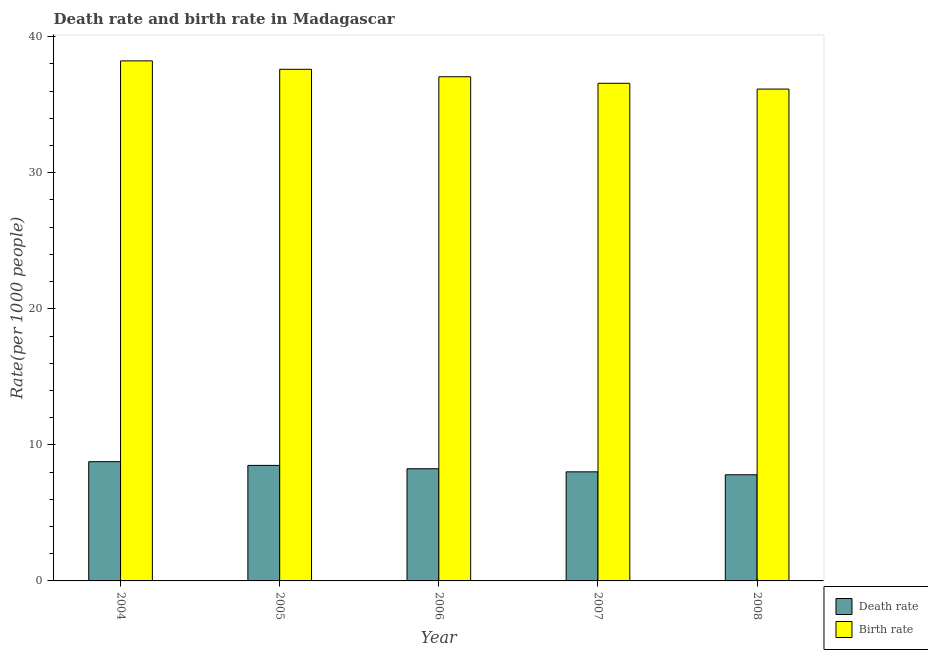How many groups of bars are there?
Offer a terse response. 5. Are the number of bars on each tick of the X-axis equal?
Make the answer very short. Yes. How many bars are there on the 5th tick from the right?
Your answer should be compact. 2. What is the death rate in 2005?
Offer a very short reply. 8.49. Across all years, what is the maximum death rate?
Your answer should be very brief. 8.76. Across all years, what is the minimum birth rate?
Keep it short and to the point. 36.15. In which year was the birth rate maximum?
Make the answer very short. 2004. In which year was the birth rate minimum?
Keep it short and to the point. 2008. What is the total birth rate in the graph?
Make the answer very short. 185.6. What is the difference between the death rate in 2006 and that in 2008?
Make the answer very short. 0.44. What is the difference between the death rate in 2006 and the birth rate in 2004?
Your answer should be very brief. -0.52. What is the average birth rate per year?
Offer a terse response. 37.12. In the year 2004, what is the difference between the birth rate and death rate?
Make the answer very short. 0. In how many years, is the birth rate greater than 4?
Give a very brief answer. 5. What is the ratio of the death rate in 2004 to that in 2008?
Provide a succinct answer. 1.12. Is the death rate in 2006 less than that in 2008?
Your response must be concise. No. What is the difference between the highest and the second highest birth rate?
Provide a short and direct response. 0.62. What is the difference between the highest and the lowest birth rate?
Keep it short and to the point. 2.07. In how many years, is the birth rate greater than the average birth rate taken over all years?
Make the answer very short. 2. Is the sum of the birth rate in 2004 and 2006 greater than the maximum death rate across all years?
Your answer should be very brief. Yes. What does the 1st bar from the left in 2005 represents?
Offer a very short reply. Death rate. What does the 1st bar from the right in 2008 represents?
Make the answer very short. Birth rate. Are all the bars in the graph horizontal?
Make the answer very short. No. How many years are there in the graph?
Keep it short and to the point. 5. What is the difference between two consecutive major ticks on the Y-axis?
Your response must be concise. 10. Are the values on the major ticks of Y-axis written in scientific E-notation?
Keep it short and to the point. No. Where does the legend appear in the graph?
Make the answer very short. Bottom right. What is the title of the graph?
Keep it short and to the point. Death rate and birth rate in Madagascar. What is the label or title of the Y-axis?
Make the answer very short. Rate(per 1000 people). What is the Rate(per 1000 people) of Death rate in 2004?
Your answer should be very brief. 8.76. What is the Rate(per 1000 people) of Birth rate in 2004?
Provide a short and direct response. 38.22. What is the Rate(per 1000 people) of Death rate in 2005?
Offer a very short reply. 8.49. What is the Rate(per 1000 people) of Birth rate in 2005?
Offer a terse response. 37.6. What is the Rate(per 1000 people) of Death rate in 2006?
Keep it short and to the point. 8.24. What is the Rate(per 1000 people) of Birth rate in 2006?
Ensure brevity in your answer.  37.05. What is the Rate(per 1000 people) in Death rate in 2007?
Keep it short and to the point. 8.02. What is the Rate(per 1000 people) of Birth rate in 2007?
Ensure brevity in your answer.  36.57. What is the Rate(per 1000 people) in Death rate in 2008?
Provide a succinct answer. 7.8. What is the Rate(per 1000 people) of Birth rate in 2008?
Your answer should be very brief. 36.15. Across all years, what is the maximum Rate(per 1000 people) in Death rate?
Provide a succinct answer. 8.76. Across all years, what is the maximum Rate(per 1000 people) in Birth rate?
Ensure brevity in your answer.  38.22. Across all years, what is the minimum Rate(per 1000 people) in Death rate?
Provide a short and direct response. 7.8. Across all years, what is the minimum Rate(per 1000 people) of Birth rate?
Your response must be concise. 36.15. What is the total Rate(per 1000 people) in Death rate in the graph?
Give a very brief answer. 41.31. What is the total Rate(per 1000 people) of Birth rate in the graph?
Offer a very short reply. 185.6. What is the difference between the Rate(per 1000 people) in Death rate in 2004 and that in 2005?
Your answer should be compact. 0.27. What is the difference between the Rate(per 1000 people) in Birth rate in 2004 and that in 2005?
Make the answer very short. 0.62. What is the difference between the Rate(per 1000 people) in Death rate in 2004 and that in 2006?
Make the answer very short. 0.52. What is the difference between the Rate(per 1000 people) in Birth rate in 2004 and that in 2006?
Ensure brevity in your answer.  1.17. What is the difference between the Rate(per 1000 people) in Death rate in 2004 and that in 2007?
Your answer should be very brief. 0.75. What is the difference between the Rate(per 1000 people) in Birth rate in 2004 and that in 2007?
Your answer should be very brief. 1.65. What is the difference between the Rate(per 1000 people) of Birth rate in 2004 and that in 2008?
Your answer should be compact. 2.07. What is the difference between the Rate(per 1000 people) of Death rate in 2005 and that in 2006?
Your answer should be very brief. 0.25. What is the difference between the Rate(per 1000 people) in Birth rate in 2005 and that in 2006?
Make the answer very short. 0.55. What is the difference between the Rate(per 1000 people) in Death rate in 2005 and that in 2007?
Your answer should be very brief. 0.47. What is the difference between the Rate(per 1000 people) in Birth rate in 2005 and that in 2007?
Provide a short and direct response. 1.03. What is the difference between the Rate(per 1000 people) of Death rate in 2005 and that in 2008?
Your answer should be compact. 0.69. What is the difference between the Rate(per 1000 people) of Birth rate in 2005 and that in 2008?
Your response must be concise. 1.45. What is the difference between the Rate(per 1000 people) in Death rate in 2006 and that in 2007?
Your answer should be compact. 0.23. What is the difference between the Rate(per 1000 people) of Birth rate in 2006 and that in 2007?
Offer a very short reply. 0.48. What is the difference between the Rate(per 1000 people) of Death rate in 2006 and that in 2008?
Provide a succinct answer. 0.44. What is the difference between the Rate(per 1000 people) in Birth rate in 2006 and that in 2008?
Ensure brevity in your answer.  0.91. What is the difference between the Rate(per 1000 people) in Death rate in 2007 and that in 2008?
Keep it short and to the point. 0.22. What is the difference between the Rate(per 1000 people) in Birth rate in 2007 and that in 2008?
Keep it short and to the point. 0.42. What is the difference between the Rate(per 1000 people) in Death rate in 2004 and the Rate(per 1000 people) in Birth rate in 2005?
Your answer should be compact. -28.84. What is the difference between the Rate(per 1000 people) in Death rate in 2004 and the Rate(per 1000 people) in Birth rate in 2006?
Offer a very short reply. -28.29. What is the difference between the Rate(per 1000 people) of Death rate in 2004 and the Rate(per 1000 people) of Birth rate in 2007?
Make the answer very short. -27.81. What is the difference between the Rate(per 1000 people) in Death rate in 2004 and the Rate(per 1000 people) in Birth rate in 2008?
Provide a succinct answer. -27.39. What is the difference between the Rate(per 1000 people) of Death rate in 2005 and the Rate(per 1000 people) of Birth rate in 2006?
Provide a succinct answer. -28.57. What is the difference between the Rate(per 1000 people) in Death rate in 2005 and the Rate(per 1000 people) in Birth rate in 2007?
Your response must be concise. -28.08. What is the difference between the Rate(per 1000 people) in Death rate in 2005 and the Rate(per 1000 people) in Birth rate in 2008?
Offer a very short reply. -27.66. What is the difference between the Rate(per 1000 people) in Death rate in 2006 and the Rate(per 1000 people) in Birth rate in 2007?
Your answer should be very brief. -28.33. What is the difference between the Rate(per 1000 people) of Death rate in 2006 and the Rate(per 1000 people) of Birth rate in 2008?
Your answer should be compact. -27.91. What is the difference between the Rate(per 1000 people) of Death rate in 2007 and the Rate(per 1000 people) of Birth rate in 2008?
Give a very brief answer. -28.13. What is the average Rate(per 1000 people) of Death rate per year?
Your answer should be compact. 8.26. What is the average Rate(per 1000 people) in Birth rate per year?
Provide a succinct answer. 37.12. In the year 2004, what is the difference between the Rate(per 1000 people) of Death rate and Rate(per 1000 people) of Birth rate?
Your answer should be compact. -29.46. In the year 2005, what is the difference between the Rate(per 1000 people) in Death rate and Rate(per 1000 people) in Birth rate?
Your answer should be compact. -29.11. In the year 2006, what is the difference between the Rate(per 1000 people) in Death rate and Rate(per 1000 people) in Birth rate?
Provide a succinct answer. -28.81. In the year 2007, what is the difference between the Rate(per 1000 people) in Death rate and Rate(per 1000 people) in Birth rate?
Your response must be concise. -28.56. In the year 2008, what is the difference between the Rate(per 1000 people) of Death rate and Rate(per 1000 people) of Birth rate?
Provide a succinct answer. -28.35. What is the ratio of the Rate(per 1000 people) in Death rate in 2004 to that in 2005?
Your answer should be compact. 1.03. What is the ratio of the Rate(per 1000 people) of Birth rate in 2004 to that in 2005?
Make the answer very short. 1.02. What is the ratio of the Rate(per 1000 people) of Death rate in 2004 to that in 2006?
Your response must be concise. 1.06. What is the ratio of the Rate(per 1000 people) in Birth rate in 2004 to that in 2006?
Your answer should be compact. 1.03. What is the ratio of the Rate(per 1000 people) in Death rate in 2004 to that in 2007?
Your answer should be compact. 1.09. What is the ratio of the Rate(per 1000 people) of Birth rate in 2004 to that in 2007?
Give a very brief answer. 1.04. What is the ratio of the Rate(per 1000 people) of Death rate in 2004 to that in 2008?
Your answer should be compact. 1.12. What is the ratio of the Rate(per 1000 people) of Birth rate in 2004 to that in 2008?
Your answer should be compact. 1.06. What is the ratio of the Rate(per 1000 people) of Death rate in 2005 to that in 2006?
Provide a short and direct response. 1.03. What is the ratio of the Rate(per 1000 people) of Birth rate in 2005 to that in 2006?
Your answer should be compact. 1.01. What is the ratio of the Rate(per 1000 people) of Death rate in 2005 to that in 2007?
Your answer should be compact. 1.06. What is the ratio of the Rate(per 1000 people) of Birth rate in 2005 to that in 2007?
Provide a succinct answer. 1.03. What is the ratio of the Rate(per 1000 people) in Death rate in 2005 to that in 2008?
Offer a terse response. 1.09. What is the ratio of the Rate(per 1000 people) in Birth rate in 2005 to that in 2008?
Offer a very short reply. 1.04. What is the ratio of the Rate(per 1000 people) in Death rate in 2006 to that in 2007?
Make the answer very short. 1.03. What is the ratio of the Rate(per 1000 people) of Birth rate in 2006 to that in 2007?
Provide a succinct answer. 1.01. What is the ratio of the Rate(per 1000 people) of Death rate in 2006 to that in 2008?
Give a very brief answer. 1.06. What is the ratio of the Rate(per 1000 people) of Birth rate in 2006 to that in 2008?
Offer a terse response. 1.03. What is the ratio of the Rate(per 1000 people) of Death rate in 2007 to that in 2008?
Offer a terse response. 1.03. What is the ratio of the Rate(per 1000 people) of Birth rate in 2007 to that in 2008?
Make the answer very short. 1.01. What is the difference between the highest and the second highest Rate(per 1000 people) of Death rate?
Provide a short and direct response. 0.27. What is the difference between the highest and the second highest Rate(per 1000 people) of Birth rate?
Provide a succinct answer. 0.62. What is the difference between the highest and the lowest Rate(per 1000 people) in Death rate?
Offer a terse response. 0.96. What is the difference between the highest and the lowest Rate(per 1000 people) in Birth rate?
Ensure brevity in your answer.  2.07. 